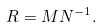Convert formula to latex. <formula><loc_0><loc_0><loc_500><loc_500>R = M N ^ { - 1 } .</formula> 